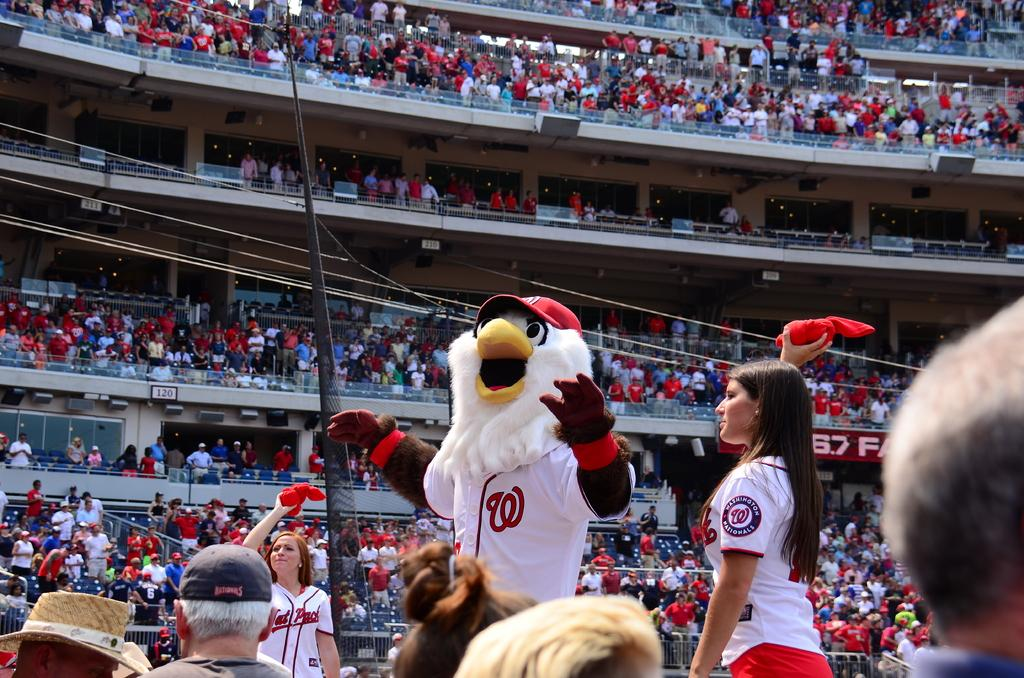<image>
Relay a brief, clear account of the picture shown. The mascot for the Nationals pumping the crowd up at a game. 